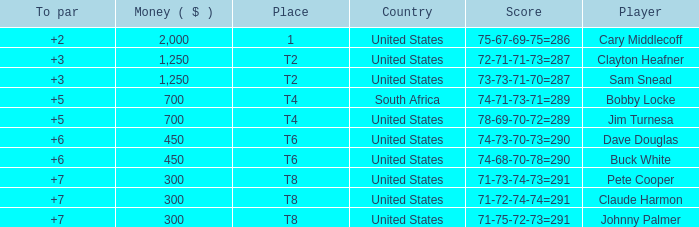What is Claude Harmon's Place? T8. 